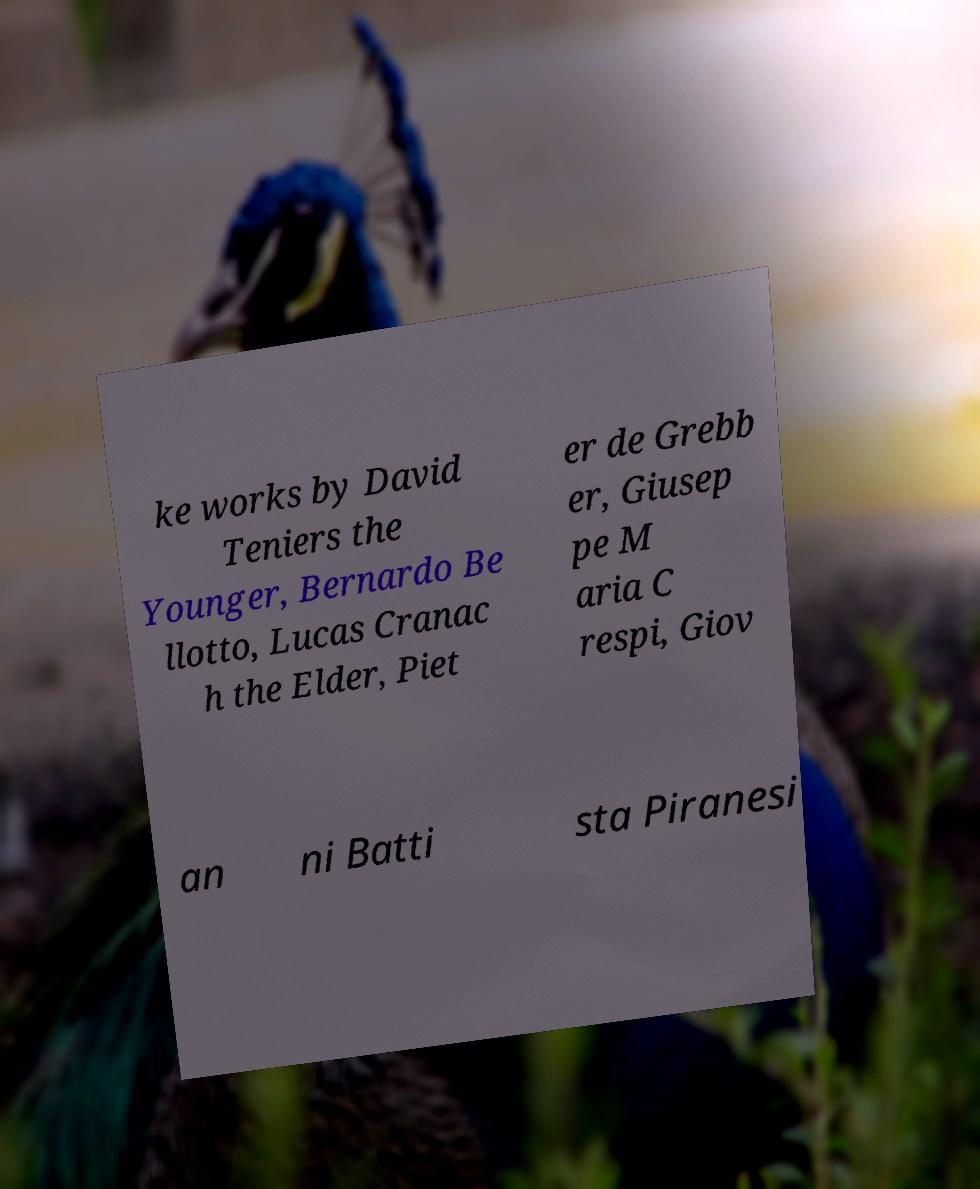What messages or text are displayed in this image? I need them in a readable, typed format. ke works by David Teniers the Younger, Bernardo Be llotto, Lucas Cranac h the Elder, Piet er de Grebb er, Giusep pe M aria C respi, Giov an ni Batti sta Piranesi 